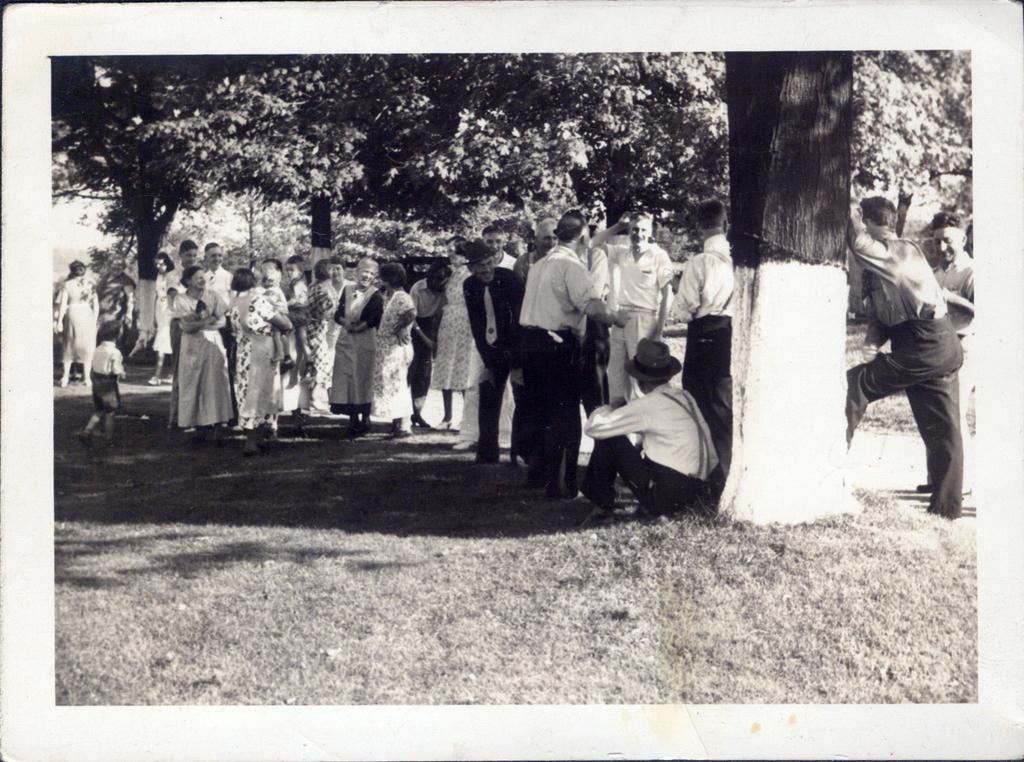In one or two sentences, can you explain what this image depicts? At the bottom of the image there is grass. In the middle of the image few people are standing and sitting. Behind them there are some trees. 